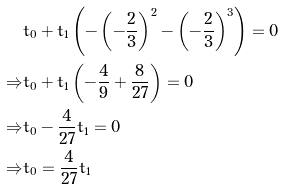<formula> <loc_0><loc_0><loc_500><loc_500>& t _ { 0 } + t _ { 1 } \left ( - \left ( - \frac { 2 } { 3 } \right ) ^ { 2 } - \left ( - \frac { 2 } { 3 } \right ) ^ { 3 } \right ) = 0 \\ \Rightarrow & t _ { 0 } + t _ { 1 } \left ( - \frac { 4 } { 9 } + \frac { 8 } { 2 7 } \right ) = 0 \\ \Rightarrow & t _ { 0 } - \frac { 4 } { 2 7 } t _ { 1 } = 0 \\ \Rightarrow & t _ { 0 } = \frac { 4 } { 2 7 } t _ { 1 }</formula> 